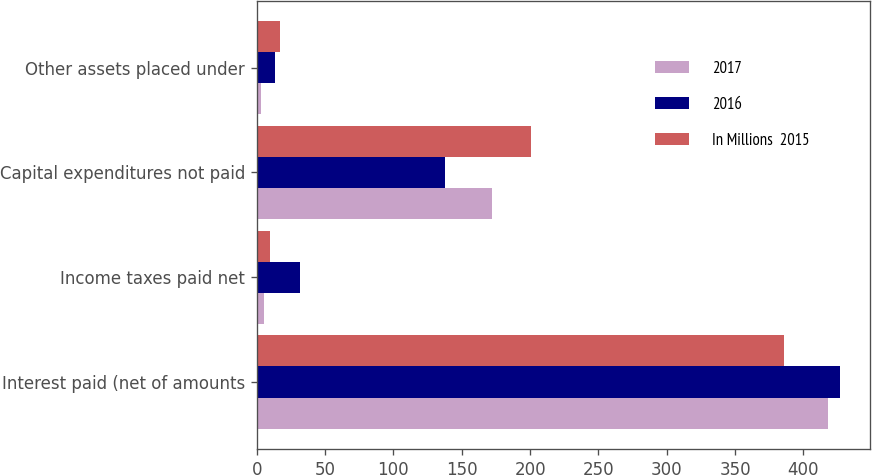Convert chart to OTSL. <chart><loc_0><loc_0><loc_500><loc_500><stacked_bar_chart><ecel><fcel>Interest paid (net of amounts<fcel>Income taxes paid net<fcel>Capital expenditures not paid<fcel>Other assets placed under<nl><fcel>2017<fcel>418<fcel>5<fcel>172<fcel>3<nl><fcel>2016<fcel>427<fcel>32<fcel>138<fcel>13<nl><fcel>In Millions  2015<fcel>386<fcel>10<fcel>201<fcel>17<nl></chart> 